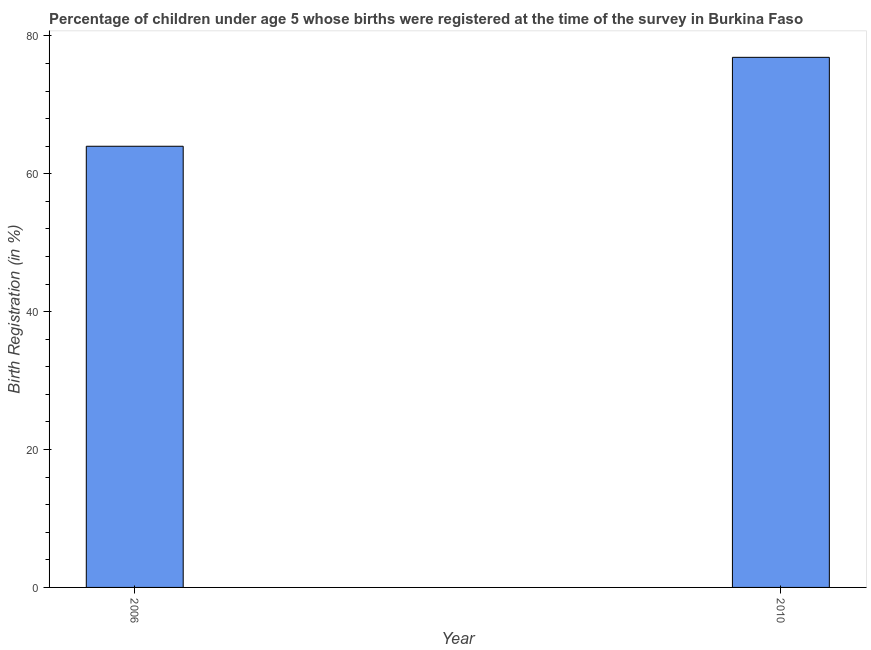Does the graph contain any zero values?
Provide a succinct answer. No. What is the title of the graph?
Your answer should be compact. Percentage of children under age 5 whose births were registered at the time of the survey in Burkina Faso. What is the label or title of the Y-axis?
Your answer should be very brief. Birth Registration (in %). What is the birth registration in 2006?
Your response must be concise. 64. Across all years, what is the maximum birth registration?
Ensure brevity in your answer.  76.9. Across all years, what is the minimum birth registration?
Ensure brevity in your answer.  64. What is the sum of the birth registration?
Provide a succinct answer. 140.9. What is the average birth registration per year?
Keep it short and to the point. 70.45. What is the median birth registration?
Offer a very short reply. 70.45. In how many years, is the birth registration greater than 52 %?
Provide a short and direct response. 2. Do a majority of the years between 2006 and 2010 (inclusive) have birth registration greater than 16 %?
Your answer should be very brief. Yes. What is the ratio of the birth registration in 2006 to that in 2010?
Ensure brevity in your answer.  0.83. In how many years, is the birth registration greater than the average birth registration taken over all years?
Your answer should be very brief. 1. Are all the bars in the graph horizontal?
Your response must be concise. No. How many years are there in the graph?
Ensure brevity in your answer.  2. What is the Birth Registration (in %) of 2010?
Make the answer very short. 76.9. What is the ratio of the Birth Registration (in %) in 2006 to that in 2010?
Provide a succinct answer. 0.83. 